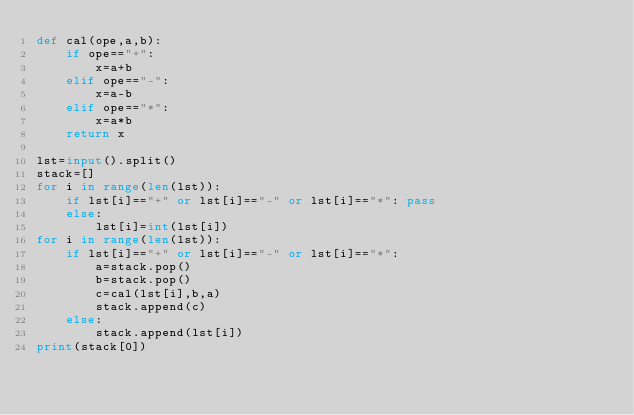Convert code to text. <code><loc_0><loc_0><loc_500><loc_500><_Python_>def cal(ope,a,b):
    if ope=="+":
        x=a+b
    elif ope=="-":
        x=a-b
    elif ope=="*":
        x=a*b
    return x

lst=input().split()
stack=[]
for i in range(len(lst)):
    if lst[i]=="+" or lst[i]=="-" or lst[i]=="*": pass
    else:
        lst[i]=int(lst[i])
for i in range(len(lst)):
    if lst[i]=="+" or lst[i]=="-" or lst[i]=="*": 
        a=stack.pop()
        b=stack.pop()
        c=cal(lst[i],b,a)
        stack.append(c)
    else:
        stack.append(lst[i])
print(stack[0])
</code> 